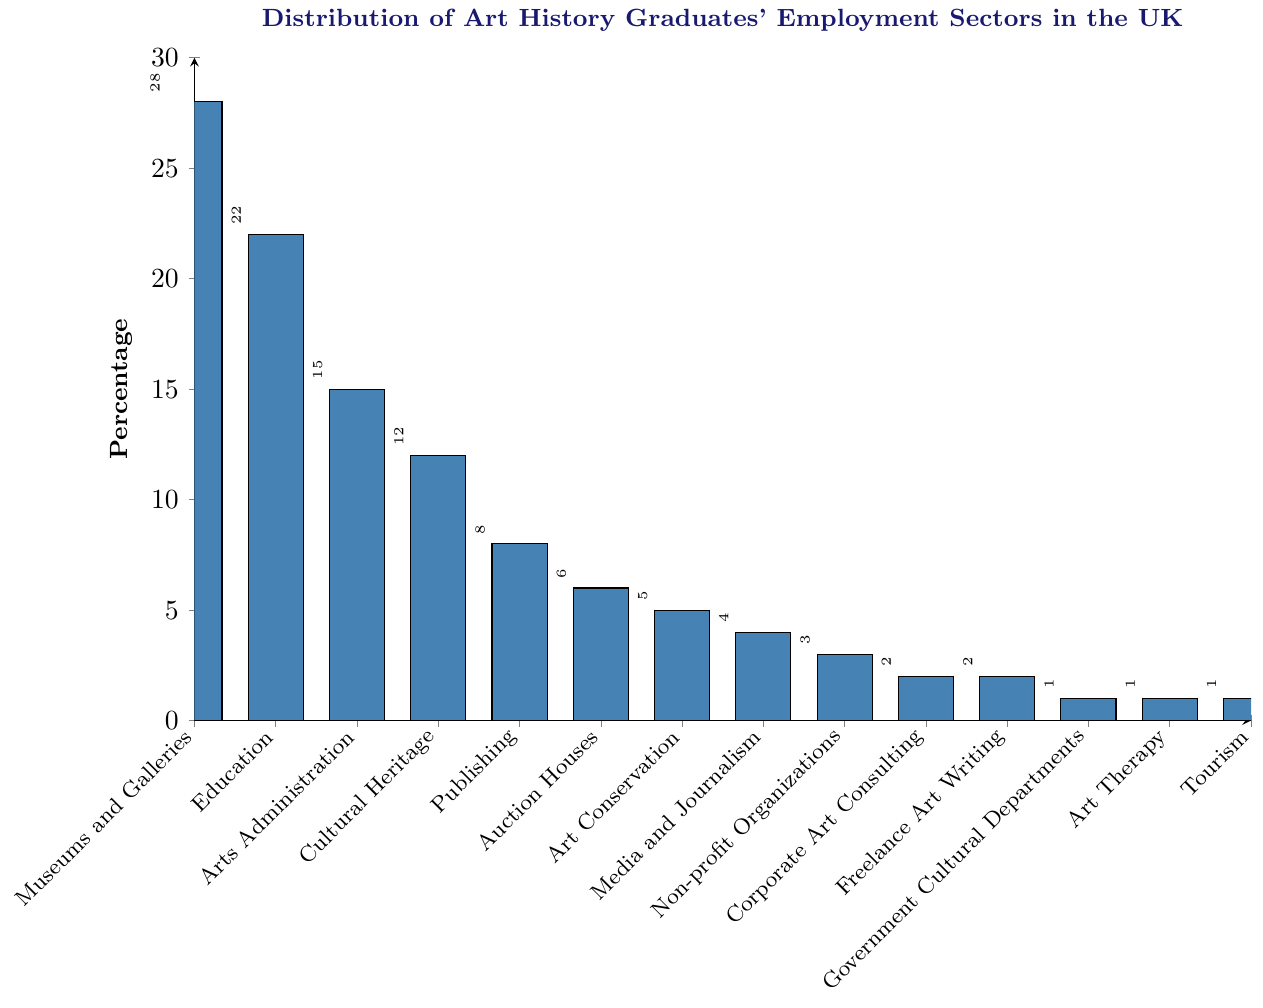What sector employs the highest percentage of art history graduates? The tallest bar on the chart represents the sector that employs the highest percentage of graduates. The bar labeled "Museums and Galleries" reaches the highest value, which is 28%.
Answer: Museums and Galleries Which sector employs fewer graduates than "Art Conservation" but more than "Corporate Art Consulting"? The bar representing "Art Conservation" is at 5%, and "Corporate Art Consulting" is at 2%. The sector that falls between these percentages is "Media and Journalism" at 4%.
Answer: Media and Journalism What's the difference in percentage between the sector with the highest employment and the sector with the second-highest employment? The sector with the highest employment is "Museums and Galleries" at 28%, and the second-highest is "Education" at 22%. The difference is calculated as 28% - 22% = 6%.
Answer: 6% List the sectors that employ 1% of art history graduates. The bars labeled "Government Cultural Departments", "Art Therapy", and "Tourism" all reach up to the 1% mark.
Answer: Government Cultural Departments, Art Therapy, Tourism What is the third most common employment sector for art history graduates? The bars show "Museums and Galleries" and "Education" as the first and second most common, with 28% and 22% respectively. The third tallest bar is labeled "Arts Administration" at 15%.
Answer: Arts Administration What percentage of art history graduates work in "Publishing" and how does it compare to those working in "Cultural Heritage"? The "Publishing" bar is at 8%, and the "Cultural Heritage" bar is at 12%. To compare, 8% is 4% less than 12%.
Answer: 8%, 4% less How many sectors employ 2% or fewer of art history graduates? The bars representing "Corporate Art Consulting", "Freelance Art Writing", "Government Cultural Departments", "Art Therapy", and "Tourism" each reach either 2% or 1%. There are 5 such sectors.
Answer: 5 Calculate the total percentage of graduates employed in "Auction Houses", "Art Conservation", and "Media and Journalism". Sum of the percentages: Auction Houses (6%) + Art Conservation (5%) + Media and Journalism (4%) = 6% + 5% + 4% = 15%.
Answer: 15% Which sector employs twice the number of graduates as "Publishing"? The "Publishing" sector is at 8%. Twice this number is 8% * 2 = 16%. The sector labeled "Arts Administration" at 15% is the closest and still lower than but near to twice the percentage of Publishing.
Answer: None What's the combined employment percentage for all sectors labeled as having less than 5%? Sum of percentages for "Auction Houses" (6%), "Art Conservation" (5%), "Media and Journalism" (4%), "Non-profit Organizations" (3%), "Corporate Art Consulting" (2%), "Freelance Art Writing" (2%), "Government Cultural Departments" (1%), "Art Therapy" (1%), "Tourism" (1%). 6% + 5% + 4% + 3% + 2% + 2% + 1% + 1% + 1% = 25%.
Answer: 25% 